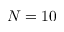<formula> <loc_0><loc_0><loc_500><loc_500>N = 1 0</formula> 